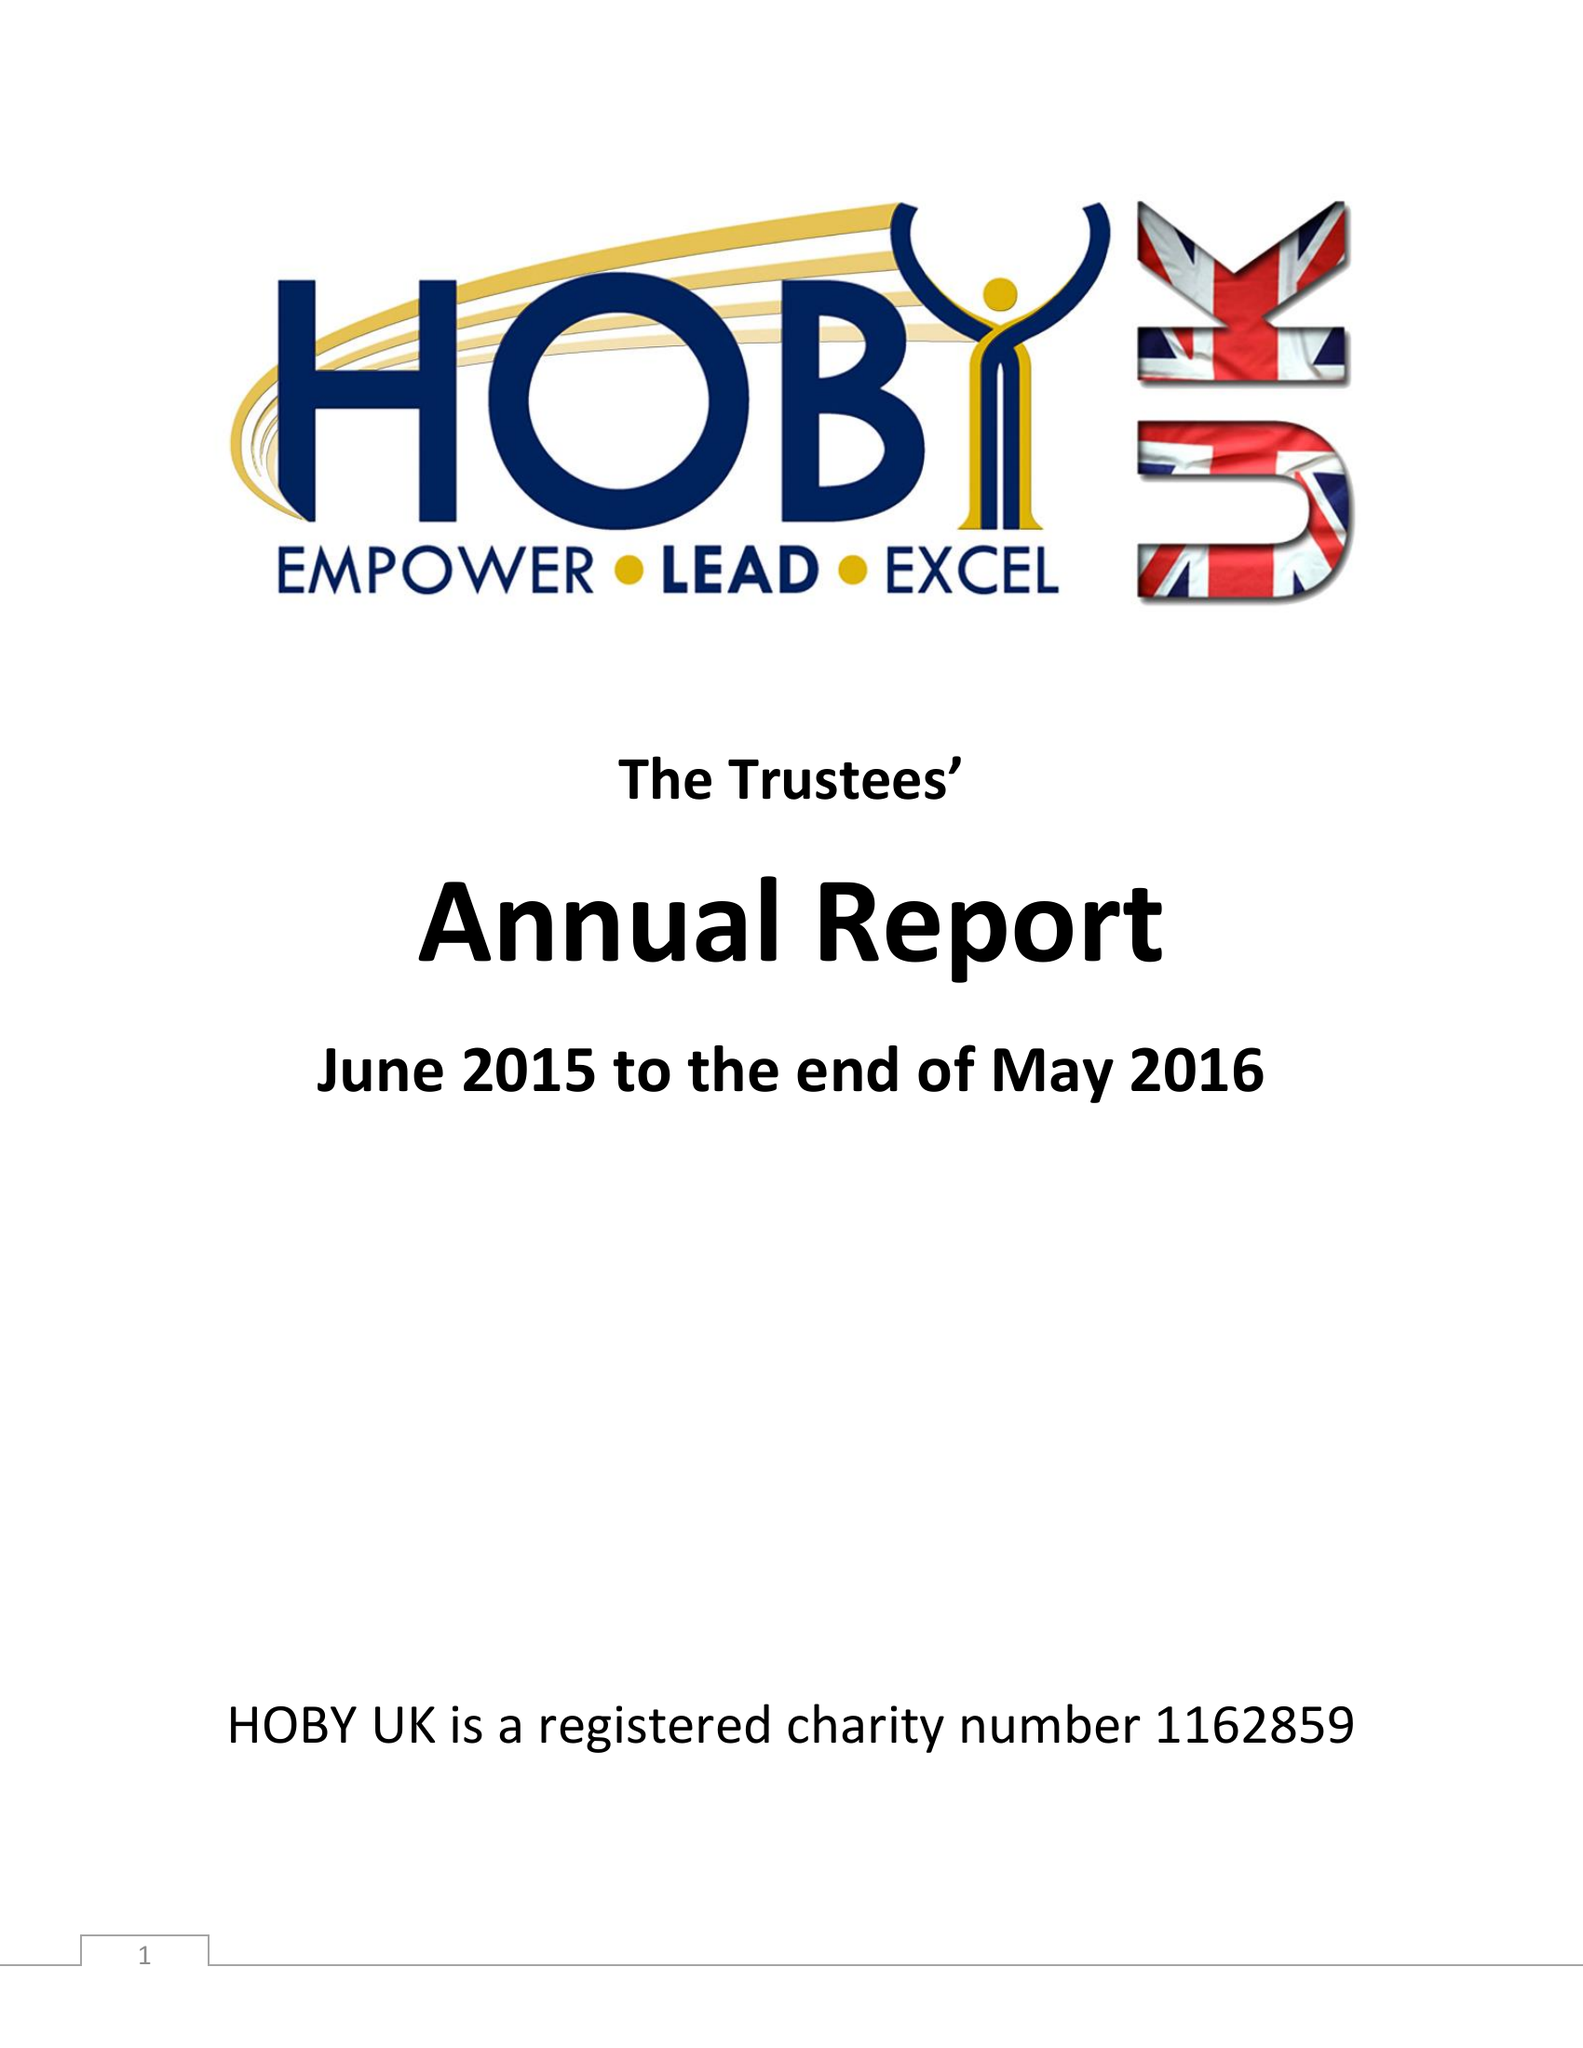What is the value for the address__postcode?
Answer the question using a single word or phrase. L18 7JR 